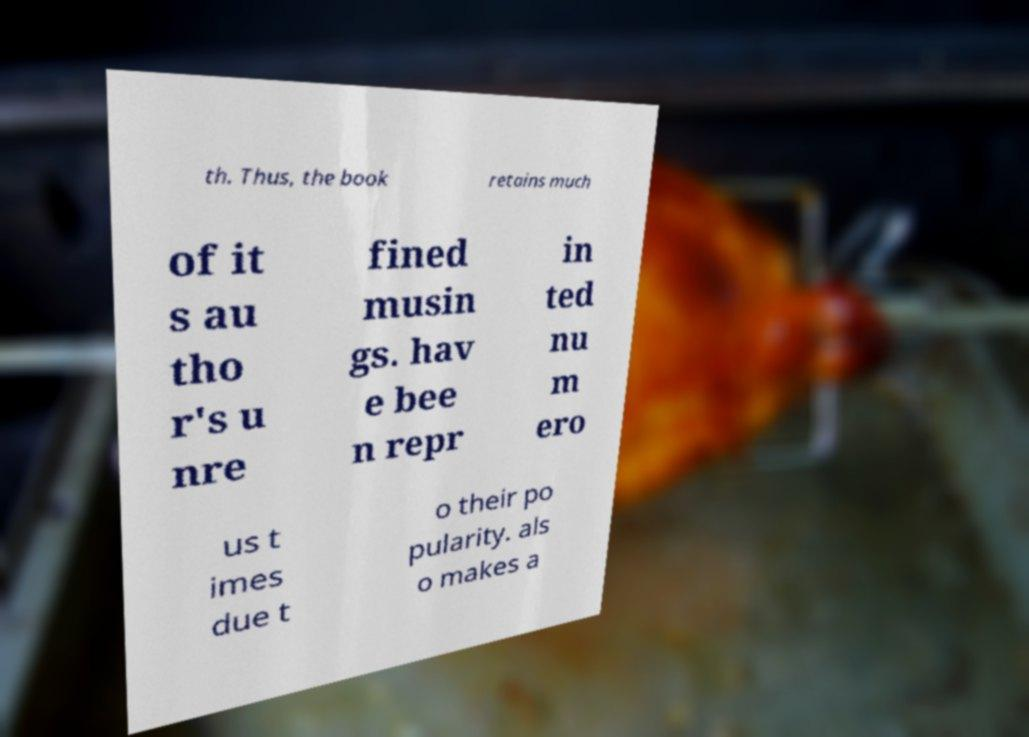Can you read and provide the text displayed in the image?This photo seems to have some interesting text. Can you extract and type it out for me? th. Thus, the book retains much of it s au tho r's u nre fined musin gs. hav e bee n repr in ted nu m ero us t imes due t o their po pularity. als o makes a 